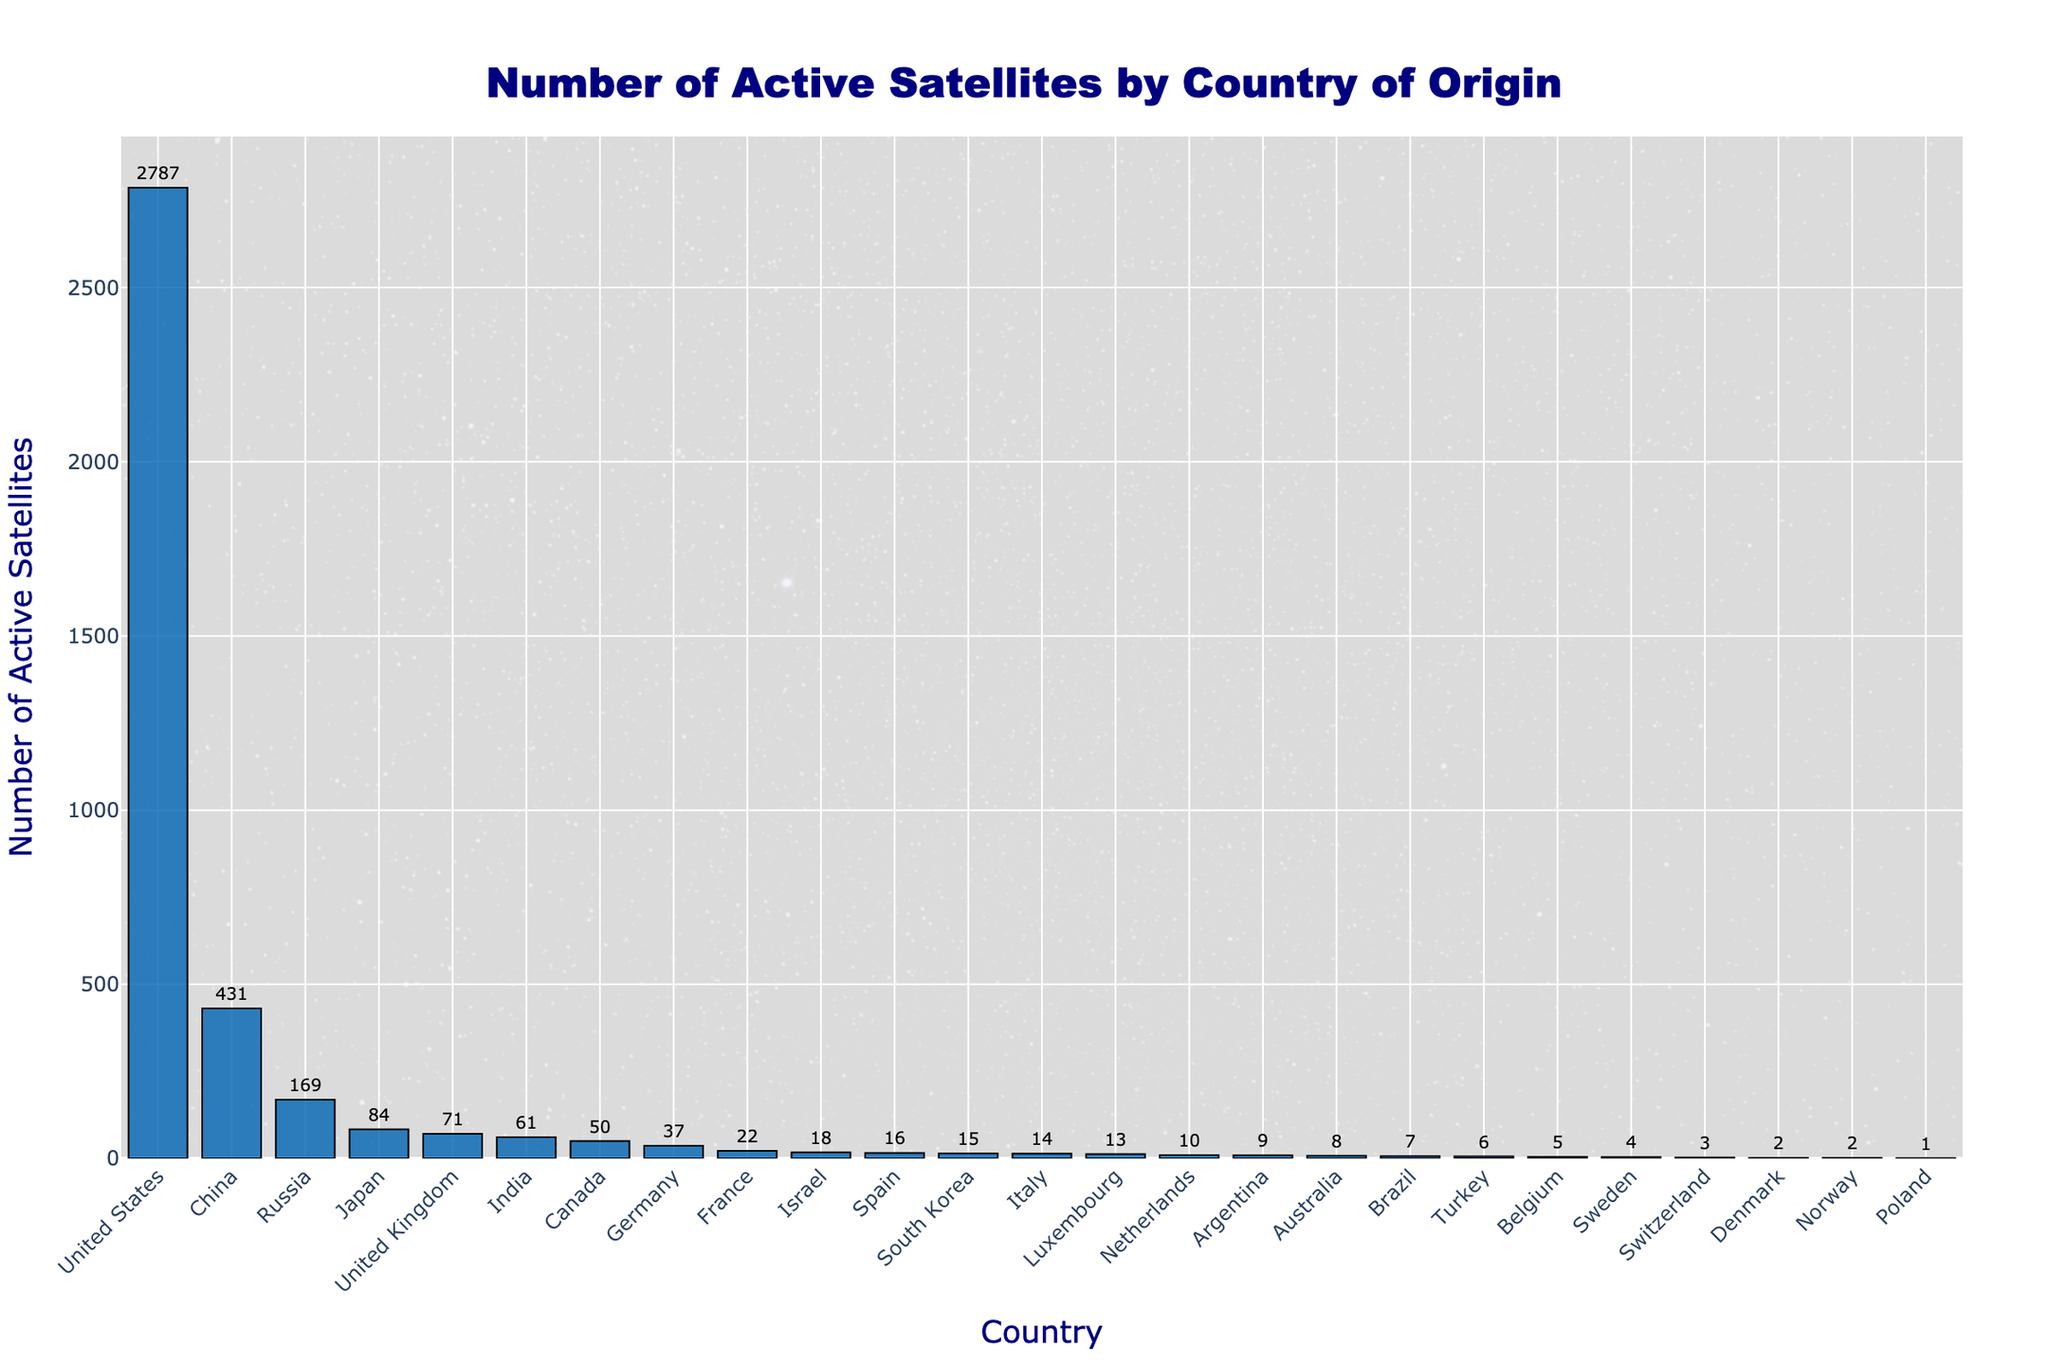What is the total number of active satellites for the top 3 countries? To find this, sum the number of active satellites for the United States, China, and Russia. 2787 + 431 + 169 = 3387
Answer: 3387 Which country has the highest number of active satellites? By looking at the height of the bars, the United States has the highest number of active satellites.
Answer: United States How many more active satellites does the United States have than China? Subtract the number of active satellites of China from that of the United States. 2787 - 431 = 2356
Answer: 2356 What is the average number of active satellites for Japan, the United Kingdom, and India? First, sum the number of active satellites for Japan, the United Kingdom, and India: 84 + 71 + 61 = 216. Then, divide by 3. 216 / 3 = 72
Answer: 72 Are there any countries with fewer than 10 active satellites? If so, name them. By observing the lengths of the bars, Argentina, Australia, Brazil, Turkey, Belgium, Sweden, Switzerland, Denmark, Norway, and Poland have fewer than 10 active satellites.
Answer: Argentina, Australia, Brazil, Turkey, Belgium, Sweden, Switzerland, Denmark, Norway, Poland Which country has the same number of active satellites as Italy? By checking the numbers, Israel has the same number of active satellites as Italy, which is 14.
Answer: Israel What is the combined number of active satellites for all European countries listed? Sum the numbers for the United Kingdom, Germany, France, Spain, Italy, Luxembourg, Netherlands, Belgium, Sweden, Switzerland, Denmark, and Norway: 71 + 37 + 22 + 16 + 14 + 13 + 10 + 5 + 4 + 3 + 2 + 2 = 199
Answer: 199 Which has more active satellites, India or Canada? By comparing the heights of their bars, India has 61 and Canada has 50, so India has more.
Answer: India Considering Spain, South Korea, and Argentina together, how many active satellites do they have? Sum the number of active satellites for Spain, South Korea, and Argentina: 16 + 15 + 9 = 40
Answer: 40 How many countries have exactly 2 active satellites? By examining the data, Denmark and Norway each have 2 active satellites.
Answer: 2 